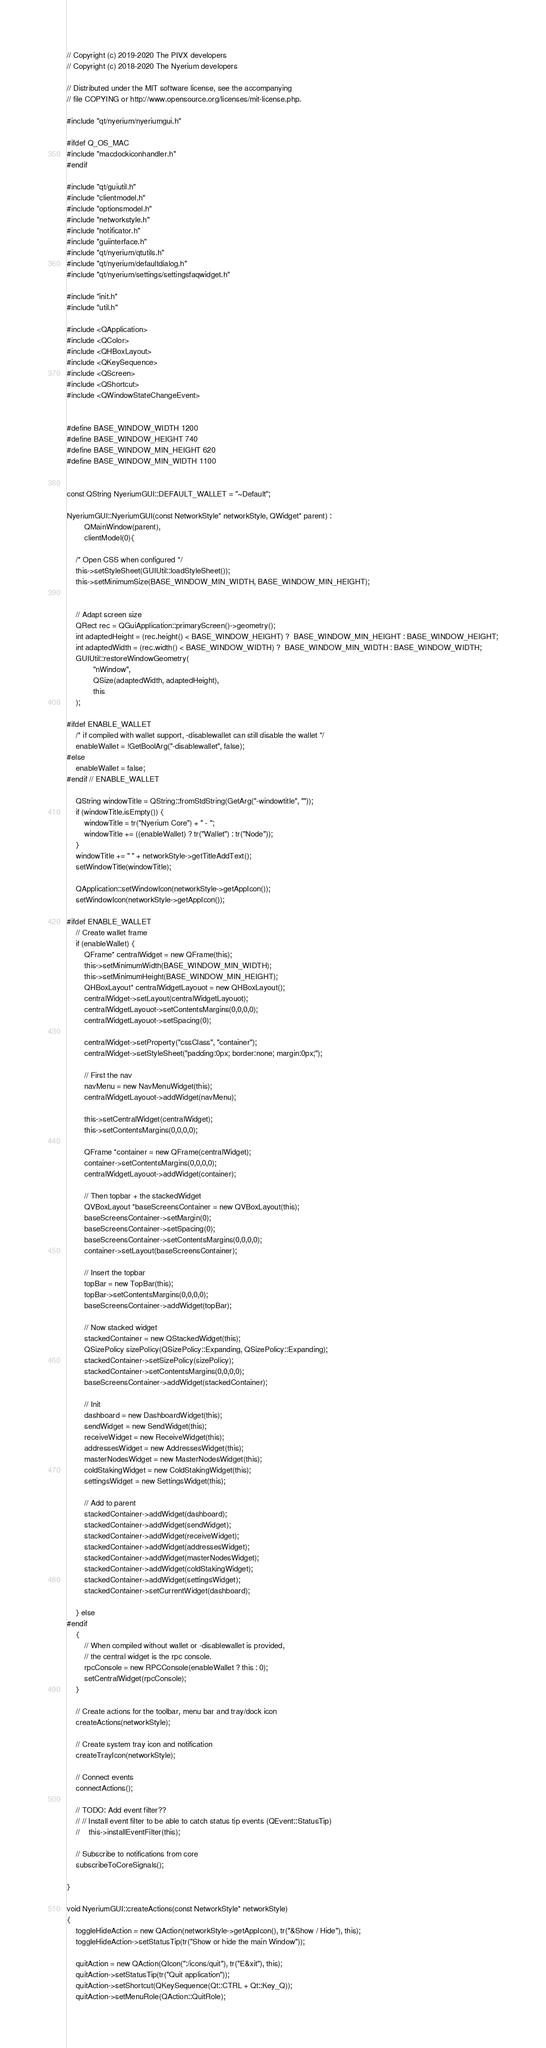Convert code to text. <code><loc_0><loc_0><loc_500><loc_500><_C++_>// Copyright (c) 2019-2020 The PIVX developers
// Copyright (c) 2018-2020 The Nyerium developers

// Distributed under the MIT software license, see the accompanying
// file COPYING or http://www.opensource.org/licenses/mit-license.php.

#include "qt/nyerium/nyeriumgui.h"

#ifdef Q_OS_MAC
#include "macdockiconhandler.h"
#endif

#include "qt/guiutil.h"
#include "clientmodel.h"
#include "optionsmodel.h"
#include "networkstyle.h"
#include "notificator.h"
#include "guiinterface.h"
#include "qt/nyerium/qtutils.h"
#include "qt/nyerium/defaultdialog.h"
#include "qt/nyerium/settings/settingsfaqwidget.h"

#include "init.h"
#include "util.h"

#include <QApplication>
#include <QColor>
#include <QHBoxLayout>
#include <QKeySequence>
#include <QScreen>
#include <QShortcut>
#include <QWindowStateChangeEvent>


#define BASE_WINDOW_WIDTH 1200
#define BASE_WINDOW_HEIGHT 740
#define BASE_WINDOW_MIN_HEIGHT 620
#define BASE_WINDOW_MIN_WIDTH 1100


const QString NyeriumGUI::DEFAULT_WALLET = "~Default";

NyeriumGUI::NyeriumGUI(const NetworkStyle* networkStyle, QWidget* parent) :
        QMainWindow(parent),
        clientModel(0){

    /* Open CSS when configured */
    this->setStyleSheet(GUIUtil::loadStyleSheet());
    this->setMinimumSize(BASE_WINDOW_MIN_WIDTH, BASE_WINDOW_MIN_HEIGHT);


    // Adapt screen size
    QRect rec = QGuiApplication::primaryScreen()->geometry();
    int adaptedHeight = (rec.height() < BASE_WINDOW_HEIGHT) ?  BASE_WINDOW_MIN_HEIGHT : BASE_WINDOW_HEIGHT;
    int adaptedWidth = (rec.width() < BASE_WINDOW_WIDTH) ?  BASE_WINDOW_MIN_WIDTH : BASE_WINDOW_WIDTH;
    GUIUtil::restoreWindowGeometry(
            "nWindow",
            QSize(adaptedWidth, adaptedHeight),
            this
    );

#ifdef ENABLE_WALLET
    /* if compiled with wallet support, -disablewallet can still disable the wallet */
    enableWallet = !GetBoolArg("-disablewallet", false);
#else
    enableWallet = false;
#endif // ENABLE_WALLET

    QString windowTitle = QString::fromStdString(GetArg("-windowtitle", ""));
    if (windowTitle.isEmpty()) {
        windowTitle = tr("Nyerium Core") + " - ";
        windowTitle += ((enableWallet) ? tr("Wallet") : tr("Node"));
    }
    windowTitle += " " + networkStyle->getTitleAddText();
    setWindowTitle(windowTitle);

    QApplication::setWindowIcon(networkStyle->getAppIcon());
    setWindowIcon(networkStyle->getAppIcon());

#ifdef ENABLE_WALLET
    // Create wallet frame
    if (enableWallet) {
        QFrame* centralWidget = new QFrame(this);
        this->setMinimumWidth(BASE_WINDOW_MIN_WIDTH);
        this->setMinimumHeight(BASE_WINDOW_MIN_HEIGHT);
        QHBoxLayout* centralWidgetLayouot = new QHBoxLayout();
        centralWidget->setLayout(centralWidgetLayouot);
        centralWidgetLayouot->setContentsMargins(0,0,0,0);
        centralWidgetLayouot->setSpacing(0);

        centralWidget->setProperty("cssClass", "container");
        centralWidget->setStyleSheet("padding:0px; border:none; margin:0px;");

        // First the nav
        navMenu = new NavMenuWidget(this);
        centralWidgetLayouot->addWidget(navMenu);

        this->setCentralWidget(centralWidget);
        this->setContentsMargins(0,0,0,0);

        QFrame *container = new QFrame(centralWidget);
        container->setContentsMargins(0,0,0,0);
        centralWidgetLayouot->addWidget(container);

        // Then topbar + the stackedWidget
        QVBoxLayout *baseScreensContainer = new QVBoxLayout(this);
        baseScreensContainer->setMargin(0);
        baseScreensContainer->setSpacing(0);
        baseScreensContainer->setContentsMargins(0,0,0,0);
        container->setLayout(baseScreensContainer);

        // Insert the topbar
        topBar = new TopBar(this);
        topBar->setContentsMargins(0,0,0,0);
        baseScreensContainer->addWidget(topBar);

        // Now stacked widget
        stackedContainer = new QStackedWidget(this);
        QSizePolicy sizePolicy(QSizePolicy::Expanding, QSizePolicy::Expanding);
        stackedContainer->setSizePolicy(sizePolicy);
        stackedContainer->setContentsMargins(0,0,0,0);
        baseScreensContainer->addWidget(stackedContainer);

        // Init
        dashboard = new DashboardWidget(this);
        sendWidget = new SendWidget(this);
        receiveWidget = new ReceiveWidget(this);
        addressesWidget = new AddressesWidget(this);
        masterNodesWidget = new MasterNodesWidget(this);
        coldStakingWidget = new ColdStakingWidget(this);
        settingsWidget = new SettingsWidget(this);

        // Add to parent
        stackedContainer->addWidget(dashboard);
        stackedContainer->addWidget(sendWidget);
        stackedContainer->addWidget(receiveWidget);
        stackedContainer->addWidget(addressesWidget);
        stackedContainer->addWidget(masterNodesWidget);
        stackedContainer->addWidget(coldStakingWidget);
        stackedContainer->addWidget(settingsWidget);
        stackedContainer->setCurrentWidget(dashboard);

    } else
#endif
    {
        // When compiled without wallet or -disablewallet is provided,
        // the central widget is the rpc console.
        rpcConsole = new RPCConsole(enableWallet ? this : 0);
        setCentralWidget(rpcConsole);
    }

    // Create actions for the toolbar, menu bar and tray/dock icon
    createActions(networkStyle);

    // Create system tray icon and notification
    createTrayIcon(networkStyle);

    // Connect events
    connectActions();

    // TODO: Add event filter??
    // // Install event filter to be able to catch status tip events (QEvent::StatusTip)
    //    this->installEventFilter(this);

    // Subscribe to notifications from core
    subscribeToCoreSignals();

}

void NyeriumGUI::createActions(const NetworkStyle* networkStyle)
{
    toggleHideAction = new QAction(networkStyle->getAppIcon(), tr("&Show / Hide"), this);
    toggleHideAction->setStatusTip(tr("Show or hide the main Window"));

    quitAction = new QAction(QIcon(":/icons/quit"), tr("E&xit"), this);
    quitAction->setStatusTip(tr("Quit application"));
    quitAction->setShortcut(QKeySequence(Qt::CTRL + Qt::Key_Q));
    quitAction->setMenuRole(QAction::QuitRole);
</code> 